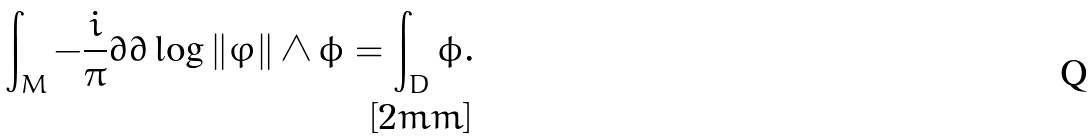Convert formula to latex. <formula><loc_0><loc_0><loc_500><loc_500>\int _ { M } - \frac { i } { \pi } \partial \bar { \partial } \log \| \varphi \| \wedge \phi = \int _ { D } \phi . \\ [ 2 m m ]</formula> 